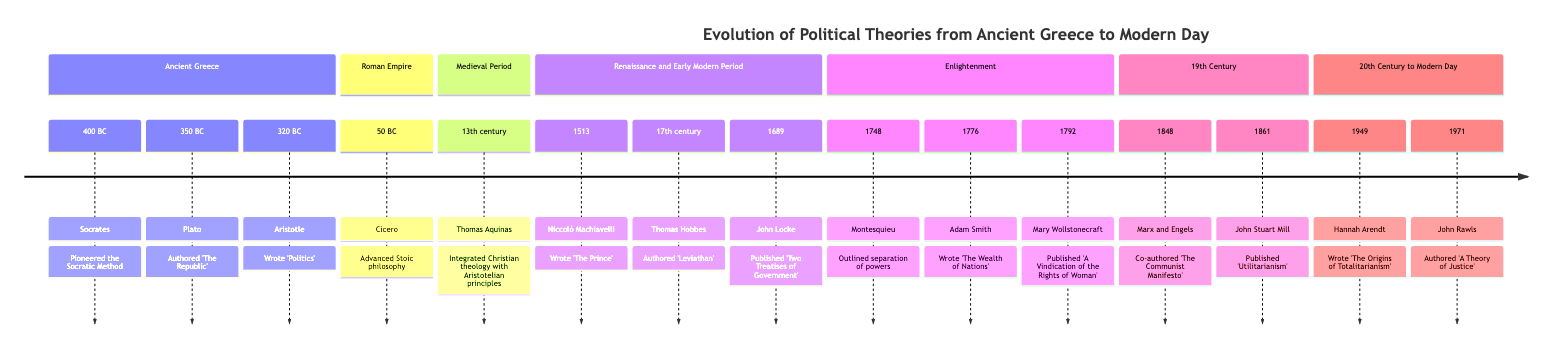What key contribution did Socrates make around 400 BC? According to the timeline, Socrates pioneered the Socratic Method, emphasizing dialogue and questioning as his key contribution circa 400 BC.
Answer: Socratic Method Who authored 'The Republic' and in what year? The timeline states that Plato authored 'The Republic' around 350 BC, indicating both the philosopher and the year of publication.
Answer: Plato, 350 BC How many milestones are listed for the Enlightenment period? By examining the timeline, there are three milestones listed under the Enlightenment period: Montesquieu in 1748, Adam Smith in 1776, and Mary Wollstonecraft in 1792, totaling three milestones.
Answer: 3 What was the primary focus of John Locke's 'Two Treatises of Government' published in 1689? The timeline indicates that John Locke's work emphasized advocating for natural rights and government by consent, which is the main focus of the treatise released in 1689.
Answer: Natural rights Which philosopher's contribution came last in the timeline? Looking at the timeline, the last entry is for John Rawls in 1971, highlighting his contribution titled 'A Theory of Justice' as the most recent in the sequence of milestones.
Answer: John Rawls What philosophical period did Niccolò Machiavelli belong to? The timeline categorizes him in the Renaissance and Early Modern Period, indicating that his work 'The Prince' is associated with that era.
Answer: Renaissance and Early Modern Period Which two philosophers co-authored 'The Communist Manifesto' and in what year? The timeline indicates that Karl Marx and Friedrich Engels co-authored 'The Communist Manifesto' in 1848, providing both the authors and the publication year.
Answer: Marx and Engels, 1848 What major theme is addressed by Hannah Arendt in 'The Origins of Totalitarianism'? According to the timeline, Hannah Arendt's major theme revolves around analyzing the nature of power and totalitarian regimes, as noted in the year 1949.
Answer: Nature of power What milestone in the Medieval Period involved Christian theology? The timeline specifies that Thomas Aquinas's work integrated Christian theology with Aristotelian principles, marking a significant milestone during the Medieval Period.
Answer: Thomas Aquinas 